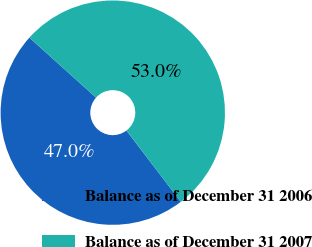<chart> <loc_0><loc_0><loc_500><loc_500><pie_chart><fcel>Balance as of December 31 2006<fcel>Balance as of December 31 2007<nl><fcel>47.03%<fcel>52.97%<nl></chart> 